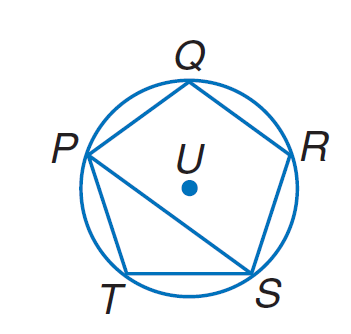Answer the mathemtical geometry problem and directly provide the correct option letter.
Question: Equilateral pentagon P Q R S T is inscribed in \odot U. Find m \angle P T S.
Choices: A: 36 B: 72 C: 120 D: 144 D 